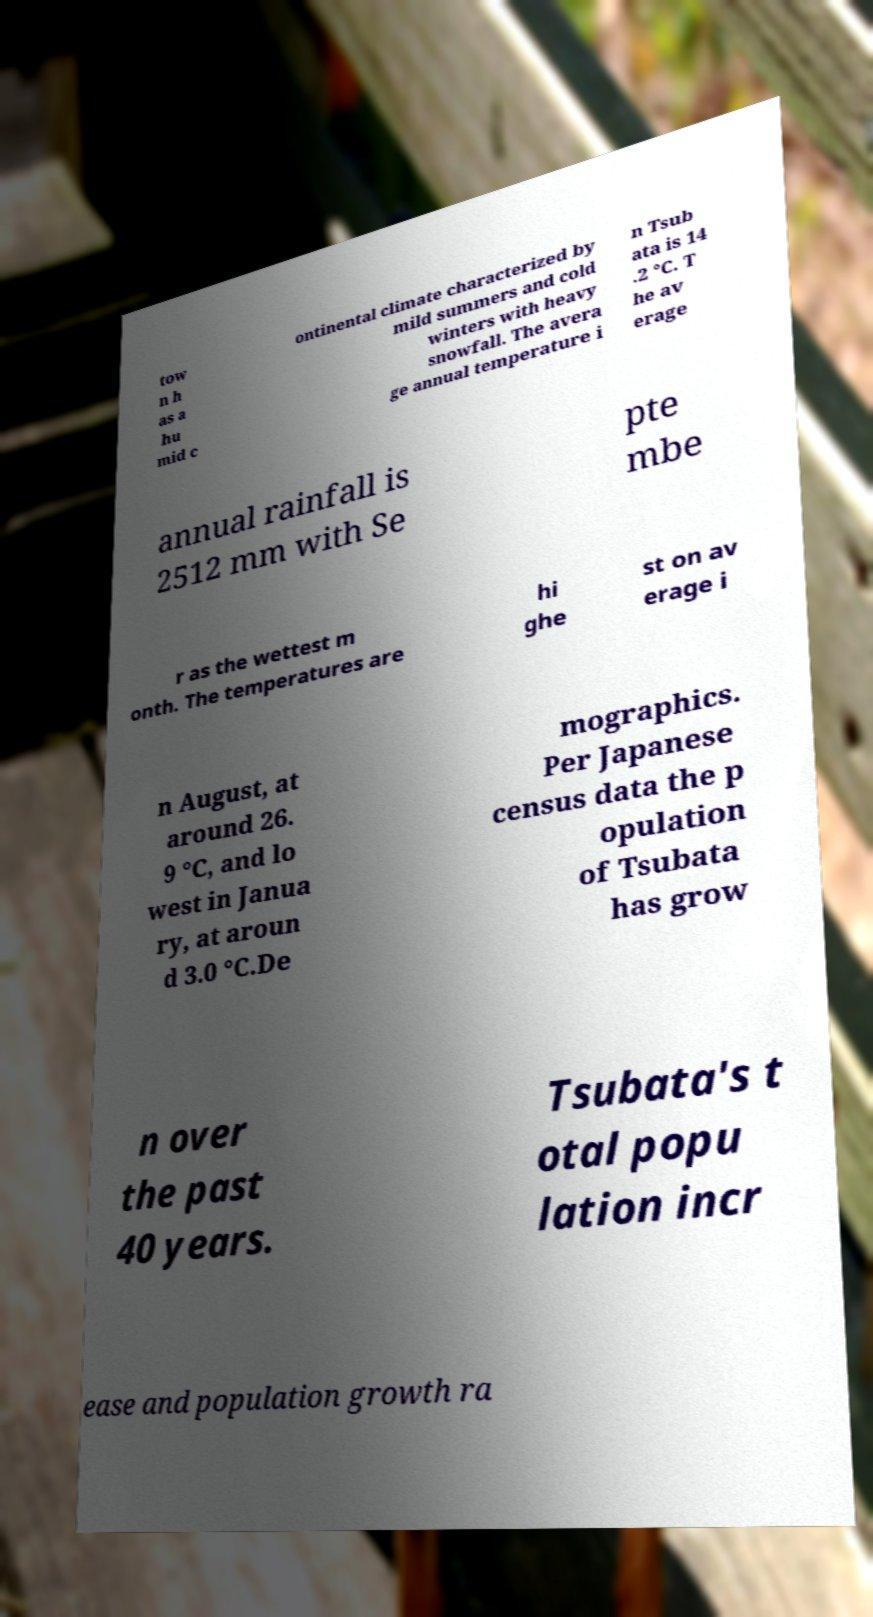Could you extract and type out the text from this image? tow n h as a hu mid c ontinental climate characterized by mild summers and cold winters with heavy snowfall. The avera ge annual temperature i n Tsub ata is 14 .2 °C. T he av erage annual rainfall is 2512 mm with Se pte mbe r as the wettest m onth. The temperatures are hi ghe st on av erage i n August, at around 26. 9 °C, and lo west in Janua ry, at aroun d 3.0 °C.De mographics. Per Japanese census data the p opulation of Tsubata has grow n over the past 40 years. Tsubata's t otal popu lation incr ease and population growth ra 